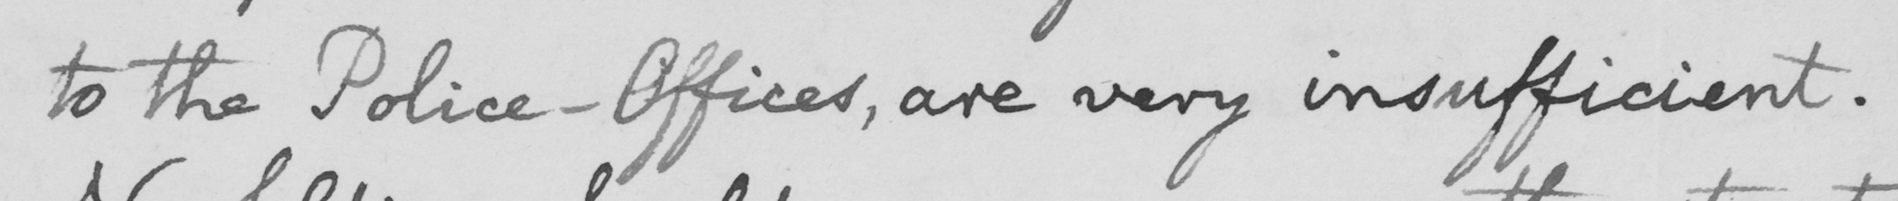Transcribe the text shown in this historical manuscript line. to the Police-Offices, are very insufficient. 